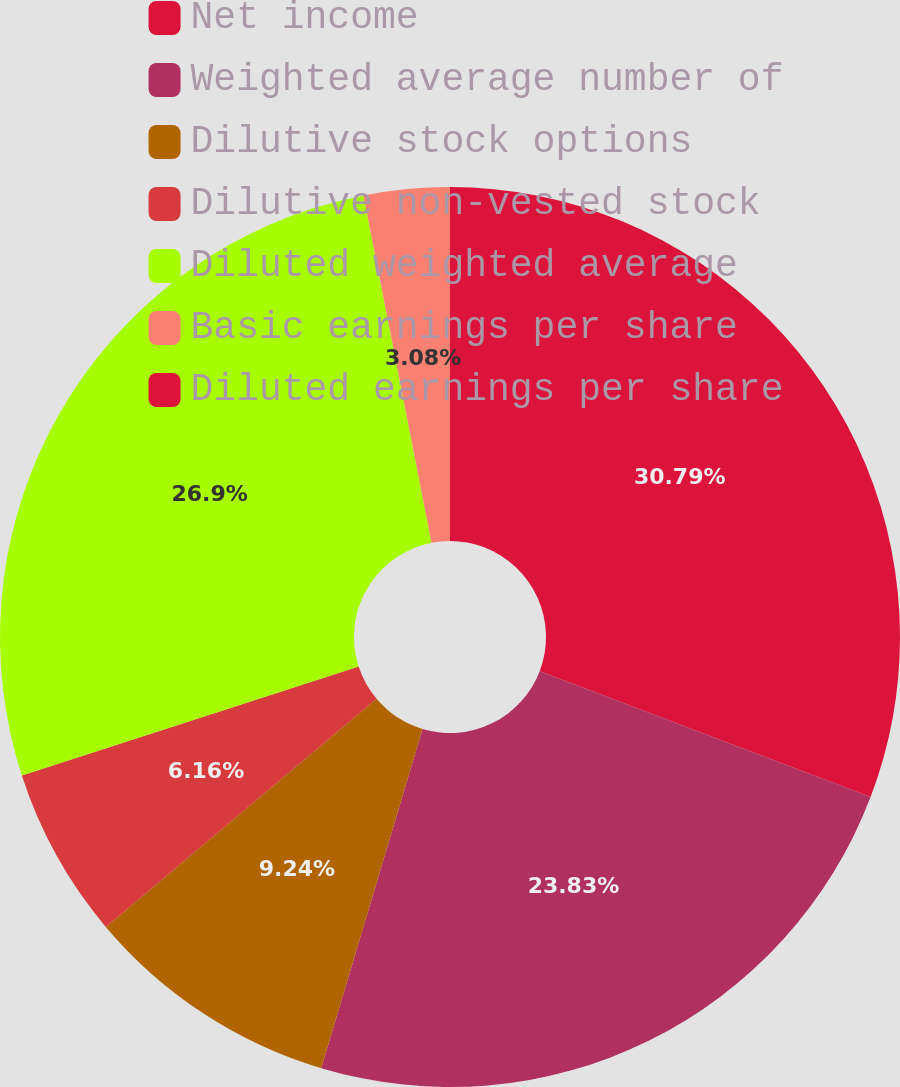<chart> <loc_0><loc_0><loc_500><loc_500><pie_chart><fcel>Net income<fcel>Weighted average number of<fcel>Dilutive stock options<fcel>Dilutive non-vested stock<fcel>Diluted weighted average<fcel>Basic earnings per share<fcel>Diluted earnings per share<nl><fcel>30.79%<fcel>23.83%<fcel>9.24%<fcel>6.16%<fcel>26.9%<fcel>3.08%<fcel>0.0%<nl></chart> 